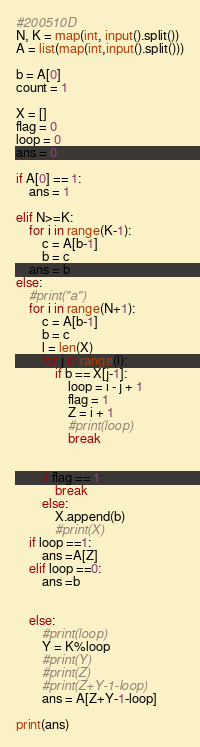<code> <loc_0><loc_0><loc_500><loc_500><_Python_>#200510D
N, K = map(int, input().split())
A = list(map(int,input().split()))
 
b = A[0]
count = 1
 
X = []
flag = 0
loop = 0
ans = 0
 
if A[0] == 1:
    ans = 1
 
elif N>=K:
    for i in range(K-1):
        c = A[b-1]
        b = c
    ans = b
else:   
    #print("a")
    for i in range(N+1):
        c = A[b-1]
        b = c
        l = len(X)
        for j in range(l):
            if b == X[j-1]:
                loop = i - j + 1
                flag = 1
                Z = i + 1
                #print(loop)
                break
 
 
        if flag == 1:
            break
        else:
            X.append(b)
            #print(X)
    if loop ==1:
        ans =A[Z]
    elif loop ==0:
        ans =b
        
    
    else:        
        #print(loop)        
        Y = K%loop
        #print(Y)
        #print(Z)
        #print(Z+Y-1-loop)
        ans = A[Z+Y-1-loop]
 
print(ans)</code> 